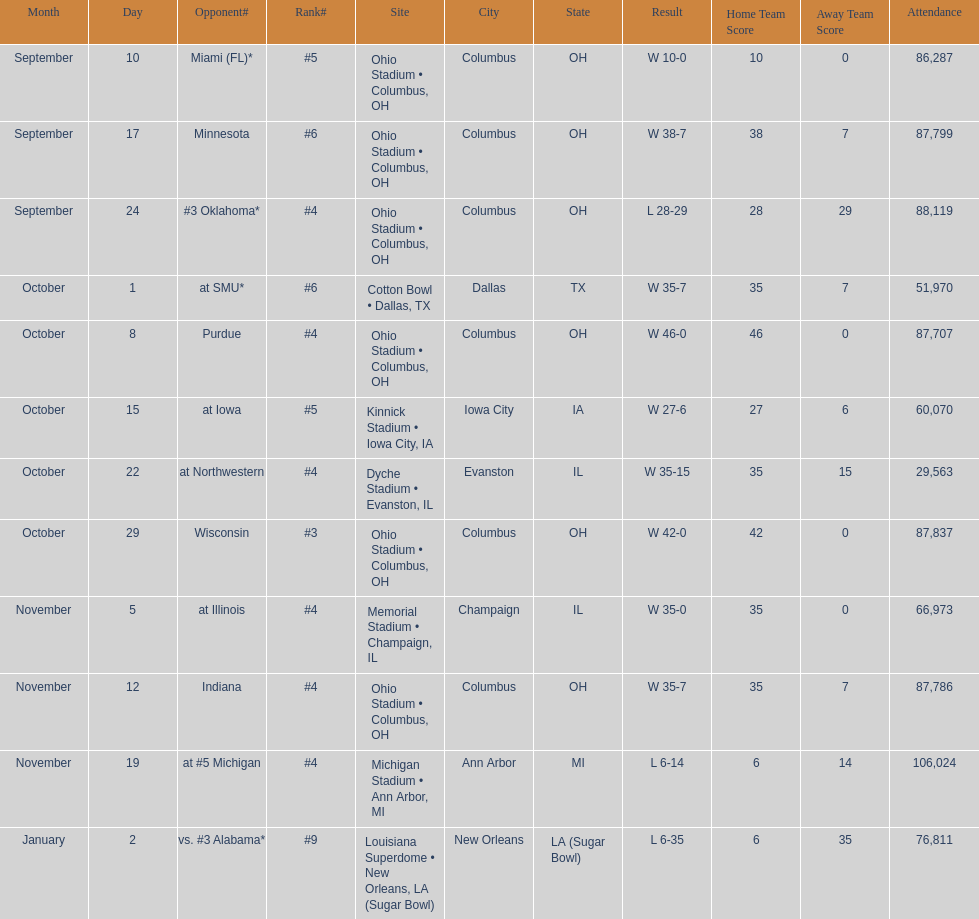What was the last game to be attended by fewer than 30,000 people? October 22. 